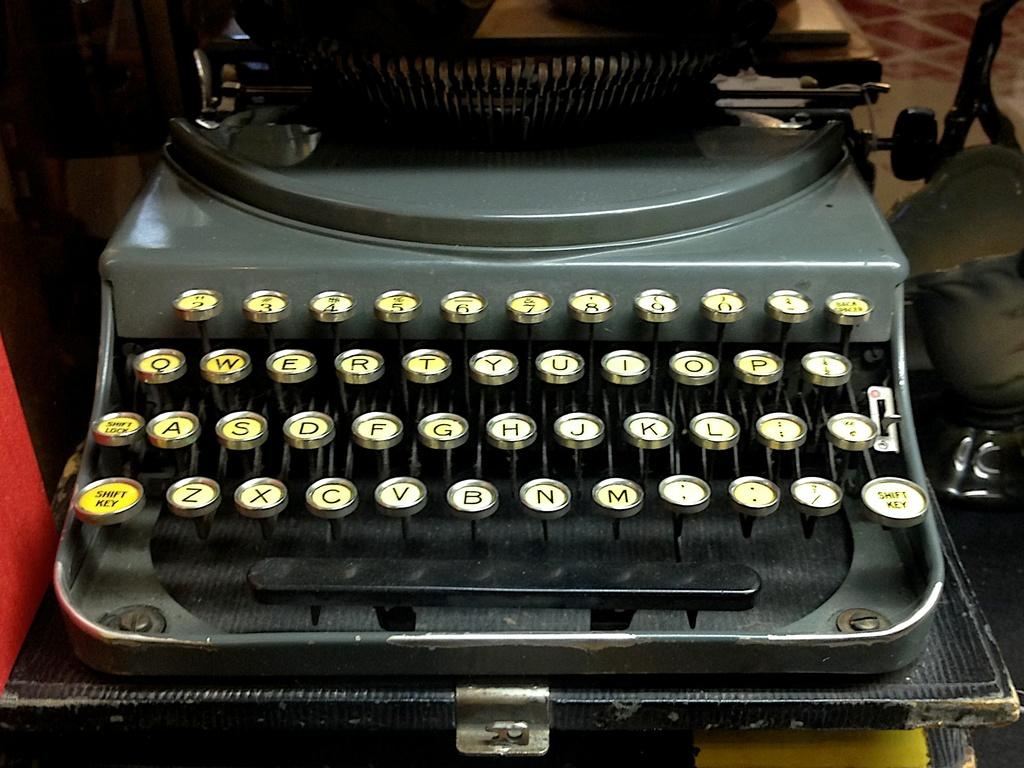<image>
Offer a succinct explanation of the picture presented. The bottom left key on the type writer is the shift key 